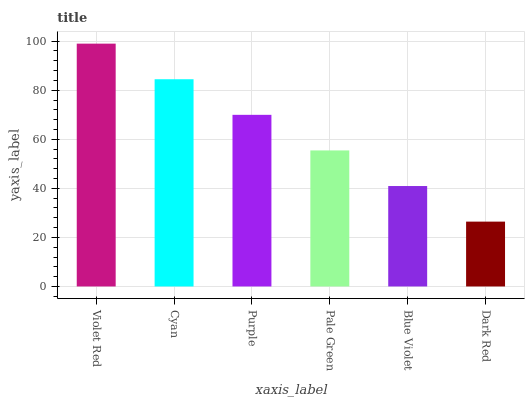Is Cyan the minimum?
Answer yes or no. No. Is Cyan the maximum?
Answer yes or no. No. Is Violet Red greater than Cyan?
Answer yes or no. Yes. Is Cyan less than Violet Red?
Answer yes or no. Yes. Is Cyan greater than Violet Red?
Answer yes or no. No. Is Violet Red less than Cyan?
Answer yes or no. No. Is Purple the high median?
Answer yes or no. Yes. Is Pale Green the low median?
Answer yes or no. Yes. Is Cyan the high median?
Answer yes or no. No. Is Violet Red the low median?
Answer yes or no. No. 